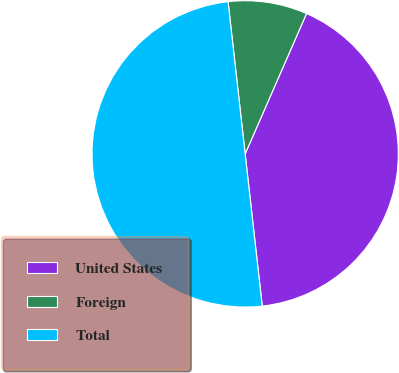<chart> <loc_0><loc_0><loc_500><loc_500><pie_chart><fcel>United States<fcel>Foreign<fcel>Total<nl><fcel>41.66%<fcel>8.34%<fcel>50.0%<nl></chart> 